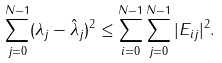Convert formula to latex. <formula><loc_0><loc_0><loc_500><loc_500>\sum _ { j = 0 } ^ { N - 1 } ( \lambda _ { j } - \hat { \lambda } _ { j } ) ^ { 2 } \leq \sum _ { i = 0 } ^ { N - 1 } \sum _ { j = 0 } ^ { N - 1 } | E _ { i j } | ^ { 2 } .</formula> 